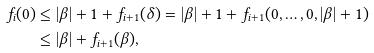<formula> <loc_0><loc_0><loc_500><loc_500>f _ { i } ( 0 ) & \leq | \beta | + 1 + f _ { i + 1 } ( \delta ) = | \beta | + 1 + f _ { i + 1 } ( 0 , \dots , 0 , | \beta | + 1 ) \\ & \leq | \beta | + f _ { i + 1 } ( \beta ) ,</formula> 